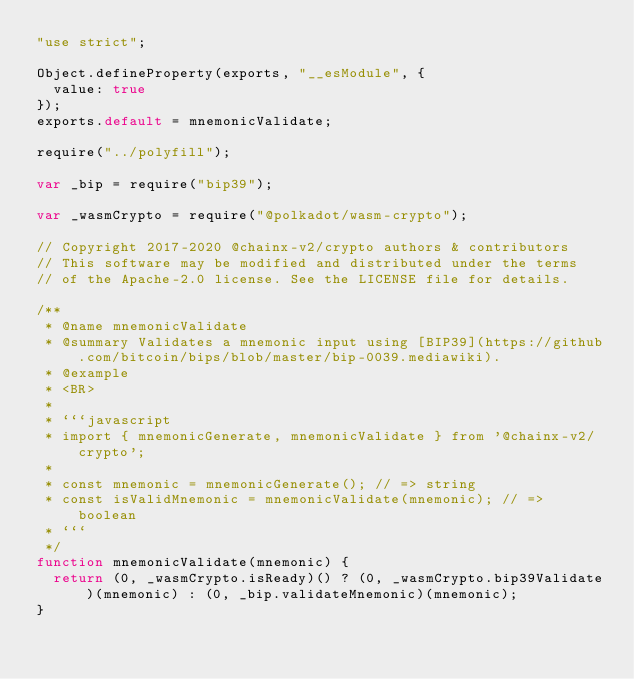<code> <loc_0><loc_0><loc_500><loc_500><_JavaScript_>"use strict";

Object.defineProperty(exports, "__esModule", {
  value: true
});
exports.default = mnemonicValidate;

require("../polyfill");

var _bip = require("bip39");

var _wasmCrypto = require("@polkadot/wasm-crypto");

// Copyright 2017-2020 @chainx-v2/crypto authors & contributors
// This software may be modified and distributed under the terms
// of the Apache-2.0 license. See the LICENSE file for details.

/**
 * @name mnemonicValidate
 * @summary Validates a mnemonic input using [BIP39](https://github.com/bitcoin/bips/blob/master/bip-0039.mediawiki).
 * @example
 * <BR>
 *
 * ```javascript
 * import { mnemonicGenerate, mnemonicValidate } from '@chainx-v2/crypto';
 *
 * const mnemonic = mnemonicGenerate(); // => string
 * const isValidMnemonic = mnemonicValidate(mnemonic); // => boolean
 * ```
 */
function mnemonicValidate(mnemonic) {
  return (0, _wasmCrypto.isReady)() ? (0, _wasmCrypto.bip39Validate)(mnemonic) : (0, _bip.validateMnemonic)(mnemonic);
}</code> 